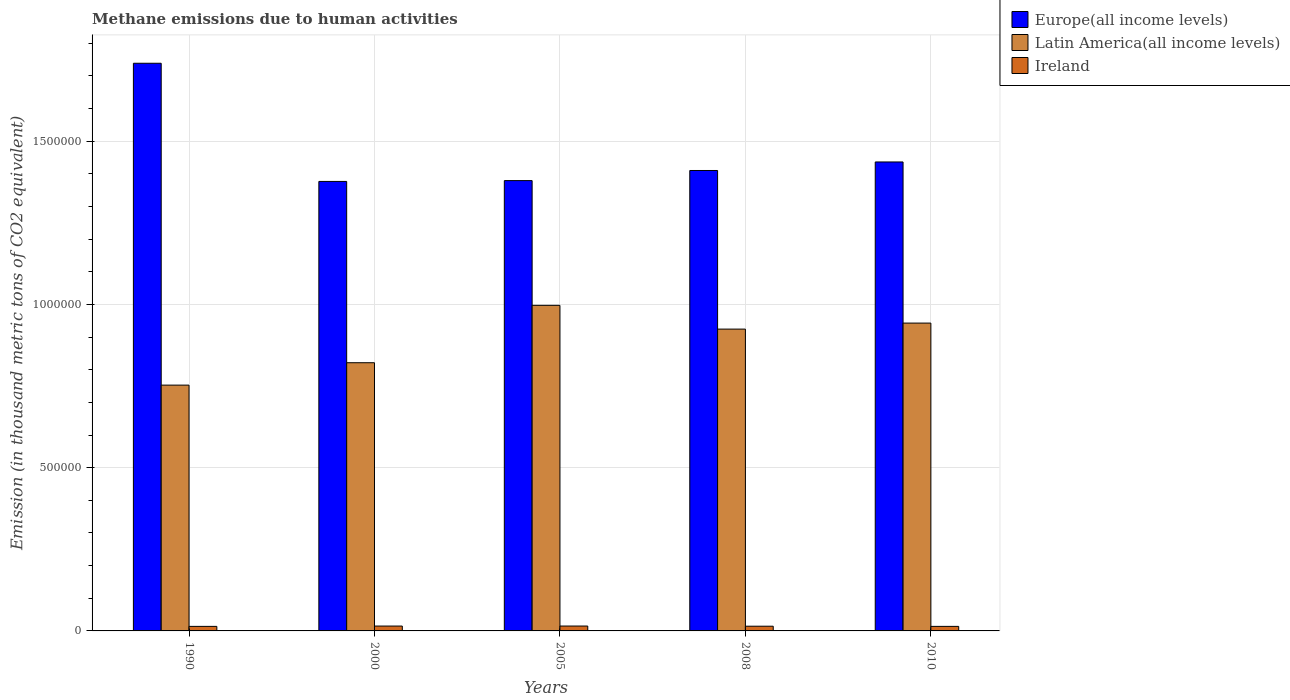Are the number of bars per tick equal to the number of legend labels?
Your response must be concise. Yes. How many bars are there on the 1st tick from the left?
Ensure brevity in your answer.  3. How many bars are there on the 2nd tick from the right?
Keep it short and to the point. 3. What is the label of the 4th group of bars from the left?
Provide a short and direct response. 2008. In how many cases, is the number of bars for a given year not equal to the number of legend labels?
Provide a succinct answer. 0. What is the amount of methane emitted in Europe(all income levels) in 2005?
Make the answer very short. 1.38e+06. Across all years, what is the maximum amount of methane emitted in Latin America(all income levels)?
Provide a short and direct response. 9.97e+05. Across all years, what is the minimum amount of methane emitted in Europe(all income levels)?
Your response must be concise. 1.38e+06. In which year was the amount of methane emitted in Europe(all income levels) maximum?
Your response must be concise. 1990. In which year was the amount of methane emitted in Latin America(all income levels) minimum?
Keep it short and to the point. 1990. What is the total amount of methane emitted in Latin America(all income levels) in the graph?
Provide a short and direct response. 4.44e+06. What is the difference between the amount of methane emitted in Ireland in 2008 and that in 2010?
Give a very brief answer. 519.6. What is the difference between the amount of methane emitted in Latin America(all income levels) in 2005 and the amount of methane emitted in Ireland in 1990?
Provide a short and direct response. 9.83e+05. What is the average amount of methane emitted in Latin America(all income levels) per year?
Provide a short and direct response. 8.88e+05. In the year 2000, what is the difference between the amount of methane emitted in Europe(all income levels) and amount of methane emitted in Latin America(all income levels)?
Your answer should be compact. 5.55e+05. In how many years, is the amount of methane emitted in Ireland greater than 300000 thousand metric tons?
Your answer should be compact. 0. What is the ratio of the amount of methane emitted in Europe(all income levels) in 1990 to that in 2005?
Offer a very short reply. 1.26. Is the amount of methane emitted in Ireland in 1990 less than that in 2010?
Make the answer very short. Yes. What is the difference between the highest and the second highest amount of methane emitted in Ireland?
Your answer should be very brief. 63.1. What is the difference between the highest and the lowest amount of methane emitted in Latin America(all income levels)?
Give a very brief answer. 2.44e+05. Is the sum of the amount of methane emitted in Ireland in 2005 and 2008 greater than the maximum amount of methane emitted in Latin America(all income levels) across all years?
Your answer should be compact. No. What does the 1st bar from the left in 2008 represents?
Offer a very short reply. Europe(all income levels). What does the 2nd bar from the right in 2008 represents?
Provide a succinct answer. Latin America(all income levels). Is it the case that in every year, the sum of the amount of methane emitted in Europe(all income levels) and amount of methane emitted in Ireland is greater than the amount of methane emitted in Latin America(all income levels)?
Keep it short and to the point. Yes. Are all the bars in the graph horizontal?
Your answer should be compact. No. How many years are there in the graph?
Offer a very short reply. 5. Are the values on the major ticks of Y-axis written in scientific E-notation?
Provide a succinct answer. No. How many legend labels are there?
Provide a succinct answer. 3. What is the title of the graph?
Give a very brief answer. Methane emissions due to human activities. What is the label or title of the X-axis?
Keep it short and to the point. Years. What is the label or title of the Y-axis?
Provide a short and direct response. Emission (in thousand metric tons of CO2 equivalent). What is the Emission (in thousand metric tons of CO2 equivalent) in Europe(all income levels) in 1990?
Provide a short and direct response. 1.74e+06. What is the Emission (in thousand metric tons of CO2 equivalent) of Latin America(all income levels) in 1990?
Give a very brief answer. 7.53e+05. What is the Emission (in thousand metric tons of CO2 equivalent) of Ireland in 1990?
Offer a very short reply. 1.39e+04. What is the Emission (in thousand metric tons of CO2 equivalent) in Europe(all income levels) in 2000?
Offer a very short reply. 1.38e+06. What is the Emission (in thousand metric tons of CO2 equivalent) of Latin America(all income levels) in 2000?
Offer a terse response. 8.21e+05. What is the Emission (in thousand metric tons of CO2 equivalent) in Ireland in 2000?
Your answer should be very brief. 1.49e+04. What is the Emission (in thousand metric tons of CO2 equivalent) of Europe(all income levels) in 2005?
Provide a short and direct response. 1.38e+06. What is the Emission (in thousand metric tons of CO2 equivalent) in Latin America(all income levels) in 2005?
Your answer should be compact. 9.97e+05. What is the Emission (in thousand metric tons of CO2 equivalent) of Ireland in 2005?
Make the answer very short. 1.50e+04. What is the Emission (in thousand metric tons of CO2 equivalent) in Europe(all income levels) in 2008?
Your answer should be very brief. 1.41e+06. What is the Emission (in thousand metric tons of CO2 equivalent) in Latin America(all income levels) in 2008?
Ensure brevity in your answer.  9.24e+05. What is the Emission (in thousand metric tons of CO2 equivalent) in Ireland in 2008?
Your response must be concise. 1.44e+04. What is the Emission (in thousand metric tons of CO2 equivalent) in Europe(all income levels) in 2010?
Keep it short and to the point. 1.44e+06. What is the Emission (in thousand metric tons of CO2 equivalent) in Latin America(all income levels) in 2010?
Ensure brevity in your answer.  9.43e+05. What is the Emission (in thousand metric tons of CO2 equivalent) of Ireland in 2010?
Ensure brevity in your answer.  1.39e+04. Across all years, what is the maximum Emission (in thousand metric tons of CO2 equivalent) in Europe(all income levels)?
Offer a terse response. 1.74e+06. Across all years, what is the maximum Emission (in thousand metric tons of CO2 equivalent) in Latin America(all income levels)?
Give a very brief answer. 9.97e+05. Across all years, what is the maximum Emission (in thousand metric tons of CO2 equivalent) in Ireland?
Offer a very short reply. 1.50e+04. Across all years, what is the minimum Emission (in thousand metric tons of CO2 equivalent) of Europe(all income levels)?
Offer a very short reply. 1.38e+06. Across all years, what is the minimum Emission (in thousand metric tons of CO2 equivalent) of Latin America(all income levels)?
Provide a short and direct response. 7.53e+05. Across all years, what is the minimum Emission (in thousand metric tons of CO2 equivalent) in Ireland?
Your answer should be compact. 1.39e+04. What is the total Emission (in thousand metric tons of CO2 equivalent) of Europe(all income levels) in the graph?
Your response must be concise. 7.34e+06. What is the total Emission (in thousand metric tons of CO2 equivalent) of Latin America(all income levels) in the graph?
Offer a terse response. 4.44e+06. What is the total Emission (in thousand metric tons of CO2 equivalent) in Ireland in the graph?
Make the answer very short. 7.21e+04. What is the difference between the Emission (in thousand metric tons of CO2 equivalent) in Europe(all income levels) in 1990 and that in 2000?
Ensure brevity in your answer.  3.62e+05. What is the difference between the Emission (in thousand metric tons of CO2 equivalent) in Latin America(all income levels) in 1990 and that in 2000?
Provide a succinct answer. -6.86e+04. What is the difference between the Emission (in thousand metric tons of CO2 equivalent) of Ireland in 1990 and that in 2000?
Ensure brevity in your answer.  -1013.1. What is the difference between the Emission (in thousand metric tons of CO2 equivalent) in Europe(all income levels) in 1990 and that in 2005?
Keep it short and to the point. 3.59e+05. What is the difference between the Emission (in thousand metric tons of CO2 equivalent) in Latin America(all income levels) in 1990 and that in 2005?
Offer a terse response. -2.44e+05. What is the difference between the Emission (in thousand metric tons of CO2 equivalent) of Ireland in 1990 and that in 2005?
Ensure brevity in your answer.  -1076.2. What is the difference between the Emission (in thousand metric tons of CO2 equivalent) in Europe(all income levels) in 1990 and that in 2008?
Make the answer very short. 3.28e+05. What is the difference between the Emission (in thousand metric tons of CO2 equivalent) of Latin America(all income levels) in 1990 and that in 2008?
Ensure brevity in your answer.  -1.72e+05. What is the difference between the Emission (in thousand metric tons of CO2 equivalent) in Ireland in 1990 and that in 2008?
Offer a very short reply. -531.2. What is the difference between the Emission (in thousand metric tons of CO2 equivalent) in Europe(all income levels) in 1990 and that in 2010?
Give a very brief answer. 3.02e+05. What is the difference between the Emission (in thousand metric tons of CO2 equivalent) in Latin America(all income levels) in 1990 and that in 2010?
Provide a short and direct response. -1.90e+05. What is the difference between the Emission (in thousand metric tons of CO2 equivalent) in Europe(all income levels) in 2000 and that in 2005?
Ensure brevity in your answer.  -2537.9. What is the difference between the Emission (in thousand metric tons of CO2 equivalent) of Latin America(all income levels) in 2000 and that in 2005?
Provide a short and direct response. -1.76e+05. What is the difference between the Emission (in thousand metric tons of CO2 equivalent) of Ireland in 2000 and that in 2005?
Your answer should be very brief. -63.1. What is the difference between the Emission (in thousand metric tons of CO2 equivalent) of Europe(all income levels) in 2000 and that in 2008?
Your response must be concise. -3.35e+04. What is the difference between the Emission (in thousand metric tons of CO2 equivalent) of Latin America(all income levels) in 2000 and that in 2008?
Provide a succinct answer. -1.03e+05. What is the difference between the Emission (in thousand metric tons of CO2 equivalent) of Ireland in 2000 and that in 2008?
Provide a short and direct response. 481.9. What is the difference between the Emission (in thousand metric tons of CO2 equivalent) of Europe(all income levels) in 2000 and that in 2010?
Offer a terse response. -5.96e+04. What is the difference between the Emission (in thousand metric tons of CO2 equivalent) in Latin America(all income levels) in 2000 and that in 2010?
Make the answer very short. -1.21e+05. What is the difference between the Emission (in thousand metric tons of CO2 equivalent) of Ireland in 2000 and that in 2010?
Your answer should be very brief. 1001.5. What is the difference between the Emission (in thousand metric tons of CO2 equivalent) of Europe(all income levels) in 2005 and that in 2008?
Offer a terse response. -3.10e+04. What is the difference between the Emission (in thousand metric tons of CO2 equivalent) in Latin America(all income levels) in 2005 and that in 2008?
Offer a terse response. 7.28e+04. What is the difference between the Emission (in thousand metric tons of CO2 equivalent) in Ireland in 2005 and that in 2008?
Make the answer very short. 545. What is the difference between the Emission (in thousand metric tons of CO2 equivalent) of Europe(all income levels) in 2005 and that in 2010?
Keep it short and to the point. -5.71e+04. What is the difference between the Emission (in thousand metric tons of CO2 equivalent) in Latin America(all income levels) in 2005 and that in 2010?
Your answer should be compact. 5.44e+04. What is the difference between the Emission (in thousand metric tons of CO2 equivalent) of Ireland in 2005 and that in 2010?
Your answer should be compact. 1064.6. What is the difference between the Emission (in thousand metric tons of CO2 equivalent) in Europe(all income levels) in 2008 and that in 2010?
Make the answer very short. -2.61e+04. What is the difference between the Emission (in thousand metric tons of CO2 equivalent) in Latin America(all income levels) in 2008 and that in 2010?
Offer a very short reply. -1.84e+04. What is the difference between the Emission (in thousand metric tons of CO2 equivalent) of Ireland in 2008 and that in 2010?
Give a very brief answer. 519.6. What is the difference between the Emission (in thousand metric tons of CO2 equivalent) in Europe(all income levels) in 1990 and the Emission (in thousand metric tons of CO2 equivalent) in Latin America(all income levels) in 2000?
Offer a terse response. 9.17e+05. What is the difference between the Emission (in thousand metric tons of CO2 equivalent) of Europe(all income levels) in 1990 and the Emission (in thousand metric tons of CO2 equivalent) of Ireland in 2000?
Give a very brief answer. 1.72e+06. What is the difference between the Emission (in thousand metric tons of CO2 equivalent) of Latin America(all income levels) in 1990 and the Emission (in thousand metric tons of CO2 equivalent) of Ireland in 2000?
Offer a very short reply. 7.38e+05. What is the difference between the Emission (in thousand metric tons of CO2 equivalent) of Europe(all income levels) in 1990 and the Emission (in thousand metric tons of CO2 equivalent) of Latin America(all income levels) in 2005?
Your response must be concise. 7.41e+05. What is the difference between the Emission (in thousand metric tons of CO2 equivalent) in Europe(all income levels) in 1990 and the Emission (in thousand metric tons of CO2 equivalent) in Ireland in 2005?
Provide a succinct answer. 1.72e+06. What is the difference between the Emission (in thousand metric tons of CO2 equivalent) in Latin America(all income levels) in 1990 and the Emission (in thousand metric tons of CO2 equivalent) in Ireland in 2005?
Give a very brief answer. 7.38e+05. What is the difference between the Emission (in thousand metric tons of CO2 equivalent) of Europe(all income levels) in 1990 and the Emission (in thousand metric tons of CO2 equivalent) of Latin America(all income levels) in 2008?
Your answer should be compact. 8.14e+05. What is the difference between the Emission (in thousand metric tons of CO2 equivalent) in Europe(all income levels) in 1990 and the Emission (in thousand metric tons of CO2 equivalent) in Ireland in 2008?
Provide a short and direct response. 1.72e+06. What is the difference between the Emission (in thousand metric tons of CO2 equivalent) of Latin America(all income levels) in 1990 and the Emission (in thousand metric tons of CO2 equivalent) of Ireland in 2008?
Offer a terse response. 7.38e+05. What is the difference between the Emission (in thousand metric tons of CO2 equivalent) of Europe(all income levels) in 1990 and the Emission (in thousand metric tons of CO2 equivalent) of Latin America(all income levels) in 2010?
Offer a very short reply. 7.96e+05. What is the difference between the Emission (in thousand metric tons of CO2 equivalent) of Europe(all income levels) in 1990 and the Emission (in thousand metric tons of CO2 equivalent) of Ireland in 2010?
Keep it short and to the point. 1.72e+06. What is the difference between the Emission (in thousand metric tons of CO2 equivalent) in Latin America(all income levels) in 1990 and the Emission (in thousand metric tons of CO2 equivalent) in Ireland in 2010?
Your response must be concise. 7.39e+05. What is the difference between the Emission (in thousand metric tons of CO2 equivalent) in Europe(all income levels) in 2000 and the Emission (in thousand metric tons of CO2 equivalent) in Latin America(all income levels) in 2005?
Your answer should be very brief. 3.79e+05. What is the difference between the Emission (in thousand metric tons of CO2 equivalent) in Europe(all income levels) in 2000 and the Emission (in thousand metric tons of CO2 equivalent) in Ireland in 2005?
Your response must be concise. 1.36e+06. What is the difference between the Emission (in thousand metric tons of CO2 equivalent) of Latin America(all income levels) in 2000 and the Emission (in thousand metric tons of CO2 equivalent) of Ireland in 2005?
Make the answer very short. 8.06e+05. What is the difference between the Emission (in thousand metric tons of CO2 equivalent) of Europe(all income levels) in 2000 and the Emission (in thousand metric tons of CO2 equivalent) of Latin America(all income levels) in 2008?
Provide a short and direct response. 4.52e+05. What is the difference between the Emission (in thousand metric tons of CO2 equivalent) of Europe(all income levels) in 2000 and the Emission (in thousand metric tons of CO2 equivalent) of Ireland in 2008?
Provide a short and direct response. 1.36e+06. What is the difference between the Emission (in thousand metric tons of CO2 equivalent) in Latin America(all income levels) in 2000 and the Emission (in thousand metric tons of CO2 equivalent) in Ireland in 2008?
Offer a very short reply. 8.07e+05. What is the difference between the Emission (in thousand metric tons of CO2 equivalent) of Europe(all income levels) in 2000 and the Emission (in thousand metric tons of CO2 equivalent) of Latin America(all income levels) in 2010?
Your response must be concise. 4.34e+05. What is the difference between the Emission (in thousand metric tons of CO2 equivalent) of Europe(all income levels) in 2000 and the Emission (in thousand metric tons of CO2 equivalent) of Ireland in 2010?
Ensure brevity in your answer.  1.36e+06. What is the difference between the Emission (in thousand metric tons of CO2 equivalent) in Latin America(all income levels) in 2000 and the Emission (in thousand metric tons of CO2 equivalent) in Ireland in 2010?
Offer a terse response. 8.07e+05. What is the difference between the Emission (in thousand metric tons of CO2 equivalent) of Europe(all income levels) in 2005 and the Emission (in thousand metric tons of CO2 equivalent) of Latin America(all income levels) in 2008?
Your response must be concise. 4.55e+05. What is the difference between the Emission (in thousand metric tons of CO2 equivalent) in Europe(all income levels) in 2005 and the Emission (in thousand metric tons of CO2 equivalent) in Ireland in 2008?
Make the answer very short. 1.36e+06. What is the difference between the Emission (in thousand metric tons of CO2 equivalent) in Latin America(all income levels) in 2005 and the Emission (in thousand metric tons of CO2 equivalent) in Ireland in 2008?
Your answer should be compact. 9.83e+05. What is the difference between the Emission (in thousand metric tons of CO2 equivalent) in Europe(all income levels) in 2005 and the Emission (in thousand metric tons of CO2 equivalent) in Latin America(all income levels) in 2010?
Ensure brevity in your answer.  4.36e+05. What is the difference between the Emission (in thousand metric tons of CO2 equivalent) in Europe(all income levels) in 2005 and the Emission (in thousand metric tons of CO2 equivalent) in Ireland in 2010?
Make the answer very short. 1.37e+06. What is the difference between the Emission (in thousand metric tons of CO2 equivalent) of Latin America(all income levels) in 2005 and the Emission (in thousand metric tons of CO2 equivalent) of Ireland in 2010?
Ensure brevity in your answer.  9.83e+05. What is the difference between the Emission (in thousand metric tons of CO2 equivalent) of Europe(all income levels) in 2008 and the Emission (in thousand metric tons of CO2 equivalent) of Latin America(all income levels) in 2010?
Your answer should be very brief. 4.67e+05. What is the difference between the Emission (in thousand metric tons of CO2 equivalent) in Europe(all income levels) in 2008 and the Emission (in thousand metric tons of CO2 equivalent) in Ireland in 2010?
Ensure brevity in your answer.  1.40e+06. What is the difference between the Emission (in thousand metric tons of CO2 equivalent) in Latin America(all income levels) in 2008 and the Emission (in thousand metric tons of CO2 equivalent) in Ireland in 2010?
Provide a short and direct response. 9.10e+05. What is the average Emission (in thousand metric tons of CO2 equivalent) in Europe(all income levels) per year?
Ensure brevity in your answer.  1.47e+06. What is the average Emission (in thousand metric tons of CO2 equivalent) of Latin America(all income levels) per year?
Your answer should be very brief. 8.88e+05. What is the average Emission (in thousand metric tons of CO2 equivalent) of Ireland per year?
Ensure brevity in your answer.  1.44e+04. In the year 1990, what is the difference between the Emission (in thousand metric tons of CO2 equivalent) of Europe(all income levels) and Emission (in thousand metric tons of CO2 equivalent) of Latin America(all income levels)?
Offer a terse response. 9.86e+05. In the year 1990, what is the difference between the Emission (in thousand metric tons of CO2 equivalent) of Europe(all income levels) and Emission (in thousand metric tons of CO2 equivalent) of Ireland?
Give a very brief answer. 1.72e+06. In the year 1990, what is the difference between the Emission (in thousand metric tons of CO2 equivalent) of Latin America(all income levels) and Emission (in thousand metric tons of CO2 equivalent) of Ireland?
Your response must be concise. 7.39e+05. In the year 2000, what is the difference between the Emission (in thousand metric tons of CO2 equivalent) of Europe(all income levels) and Emission (in thousand metric tons of CO2 equivalent) of Latin America(all income levels)?
Your response must be concise. 5.55e+05. In the year 2000, what is the difference between the Emission (in thousand metric tons of CO2 equivalent) in Europe(all income levels) and Emission (in thousand metric tons of CO2 equivalent) in Ireland?
Provide a short and direct response. 1.36e+06. In the year 2000, what is the difference between the Emission (in thousand metric tons of CO2 equivalent) in Latin America(all income levels) and Emission (in thousand metric tons of CO2 equivalent) in Ireland?
Provide a succinct answer. 8.06e+05. In the year 2005, what is the difference between the Emission (in thousand metric tons of CO2 equivalent) in Europe(all income levels) and Emission (in thousand metric tons of CO2 equivalent) in Latin America(all income levels)?
Give a very brief answer. 3.82e+05. In the year 2005, what is the difference between the Emission (in thousand metric tons of CO2 equivalent) of Europe(all income levels) and Emission (in thousand metric tons of CO2 equivalent) of Ireland?
Keep it short and to the point. 1.36e+06. In the year 2005, what is the difference between the Emission (in thousand metric tons of CO2 equivalent) in Latin America(all income levels) and Emission (in thousand metric tons of CO2 equivalent) in Ireland?
Provide a succinct answer. 9.82e+05. In the year 2008, what is the difference between the Emission (in thousand metric tons of CO2 equivalent) in Europe(all income levels) and Emission (in thousand metric tons of CO2 equivalent) in Latin America(all income levels)?
Your answer should be compact. 4.86e+05. In the year 2008, what is the difference between the Emission (in thousand metric tons of CO2 equivalent) of Europe(all income levels) and Emission (in thousand metric tons of CO2 equivalent) of Ireland?
Ensure brevity in your answer.  1.40e+06. In the year 2008, what is the difference between the Emission (in thousand metric tons of CO2 equivalent) in Latin America(all income levels) and Emission (in thousand metric tons of CO2 equivalent) in Ireland?
Give a very brief answer. 9.10e+05. In the year 2010, what is the difference between the Emission (in thousand metric tons of CO2 equivalent) of Europe(all income levels) and Emission (in thousand metric tons of CO2 equivalent) of Latin America(all income levels)?
Make the answer very short. 4.93e+05. In the year 2010, what is the difference between the Emission (in thousand metric tons of CO2 equivalent) in Europe(all income levels) and Emission (in thousand metric tons of CO2 equivalent) in Ireland?
Provide a short and direct response. 1.42e+06. In the year 2010, what is the difference between the Emission (in thousand metric tons of CO2 equivalent) in Latin America(all income levels) and Emission (in thousand metric tons of CO2 equivalent) in Ireland?
Provide a short and direct response. 9.29e+05. What is the ratio of the Emission (in thousand metric tons of CO2 equivalent) of Europe(all income levels) in 1990 to that in 2000?
Your answer should be compact. 1.26. What is the ratio of the Emission (in thousand metric tons of CO2 equivalent) in Latin America(all income levels) in 1990 to that in 2000?
Your answer should be very brief. 0.92. What is the ratio of the Emission (in thousand metric tons of CO2 equivalent) in Ireland in 1990 to that in 2000?
Your answer should be very brief. 0.93. What is the ratio of the Emission (in thousand metric tons of CO2 equivalent) in Europe(all income levels) in 1990 to that in 2005?
Offer a very short reply. 1.26. What is the ratio of the Emission (in thousand metric tons of CO2 equivalent) of Latin America(all income levels) in 1990 to that in 2005?
Your answer should be very brief. 0.76. What is the ratio of the Emission (in thousand metric tons of CO2 equivalent) in Ireland in 1990 to that in 2005?
Your response must be concise. 0.93. What is the ratio of the Emission (in thousand metric tons of CO2 equivalent) in Europe(all income levels) in 1990 to that in 2008?
Offer a terse response. 1.23. What is the ratio of the Emission (in thousand metric tons of CO2 equivalent) in Latin America(all income levels) in 1990 to that in 2008?
Make the answer very short. 0.81. What is the ratio of the Emission (in thousand metric tons of CO2 equivalent) in Ireland in 1990 to that in 2008?
Offer a terse response. 0.96. What is the ratio of the Emission (in thousand metric tons of CO2 equivalent) of Europe(all income levels) in 1990 to that in 2010?
Your answer should be compact. 1.21. What is the ratio of the Emission (in thousand metric tons of CO2 equivalent) of Latin America(all income levels) in 1990 to that in 2010?
Provide a succinct answer. 0.8. What is the ratio of the Emission (in thousand metric tons of CO2 equivalent) of Europe(all income levels) in 2000 to that in 2005?
Your response must be concise. 1. What is the ratio of the Emission (in thousand metric tons of CO2 equivalent) of Latin America(all income levels) in 2000 to that in 2005?
Offer a very short reply. 0.82. What is the ratio of the Emission (in thousand metric tons of CO2 equivalent) of Ireland in 2000 to that in 2005?
Offer a very short reply. 1. What is the ratio of the Emission (in thousand metric tons of CO2 equivalent) of Europe(all income levels) in 2000 to that in 2008?
Keep it short and to the point. 0.98. What is the ratio of the Emission (in thousand metric tons of CO2 equivalent) of Latin America(all income levels) in 2000 to that in 2008?
Keep it short and to the point. 0.89. What is the ratio of the Emission (in thousand metric tons of CO2 equivalent) in Ireland in 2000 to that in 2008?
Make the answer very short. 1.03. What is the ratio of the Emission (in thousand metric tons of CO2 equivalent) in Europe(all income levels) in 2000 to that in 2010?
Your answer should be compact. 0.96. What is the ratio of the Emission (in thousand metric tons of CO2 equivalent) of Latin America(all income levels) in 2000 to that in 2010?
Give a very brief answer. 0.87. What is the ratio of the Emission (in thousand metric tons of CO2 equivalent) in Ireland in 2000 to that in 2010?
Keep it short and to the point. 1.07. What is the ratio of the Emission (in thousand metric tons of CO2 equivalent) of Latin America(all income levels) in 2005 to that in 2008?
Provide a short and direct response. 1.08. What is the ratio of the Emission (in thousand metric tons of CO2 equivalent) of Ireland in 2005 to that in 2008?
Your response must be concise. 1.04. What is the ratio of the Emission (in thousand metric tons of CO2 equivalent) of Europe(all income levels) in 2005 to that in 2010?
Your answer should be compact. 0.96. What is the ratio of the Emission (in thousand metric tons of CO2 equivalent) in Latin America(all income levels) in 2005 to that in 2010?
Give a very brief answer. 1.06. What is the ratio of the Emission (in thousand metric tons of CO2 equivalent) in Ireland in 2005 to that in 2010?
Your answer should be very brief. 1.08. What is the ratio of the Emission (in thousand metric tons of CO2 equivalent) of Europe(all income levels) in 2008 to that in 2010?
Ensure brevity in your answer.  0.98. What is the ratio of the Emission (in thousand metric tons of CO2 equivalent) of Latin America(all income levels) in 2008 to that in 2010?
Offer a terse response. 0.98. What is the ratio of the Emission (in thousand metric tons of CO2 equivalent) in Ireland in 2008 to that in 2010?
Provide a short and direct response. 1.04. What is the difference between the highest and the second highest Emission (in thousand metric tons of CO2 equivalent) in Europe(all income levels)?
Give a very brief answer. 3.02e+05. What is the difference between the highest and the second highest Emission (in thousand metric tons of CO2 equivalent) in Latin America(all income levels)?
Keep it short and to the point. 5.44e+04. What is the difference between the highest and the second highest Emission (in thousand metric tons of CO2 equivalent) in Ireland?
Your answer should be compact. 63.1. What is the difference between the highest and the lowest Emission (in thousand metric tons of CO2 equivalent) in Europe(all income levels)?
Offer a very short reply. 3.62e+05. What is the difference between the highest and the lowest Emission (in thousand metric tons of CO2 equivalent) in Latin America(all income levels)?
Ensure brevity in your answer.  2.44e+05. What is the difference between the highest and the lowest Emission (in thousand metric tons of CO2 equivalent) of Ireland?
Your answer should be compact. 1076.2. 